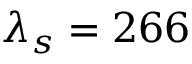Convert formula to latex. <formula><loc_0><loc_0><loc_500><loc_500>\lambda _ { s } = 2 6 6</formula> 